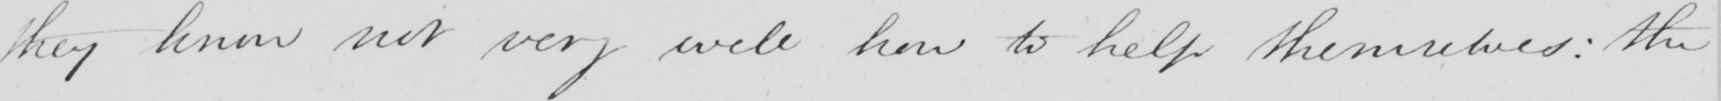Can you tell me what this handwritten text says? they know not very well how to help themselves :  the 